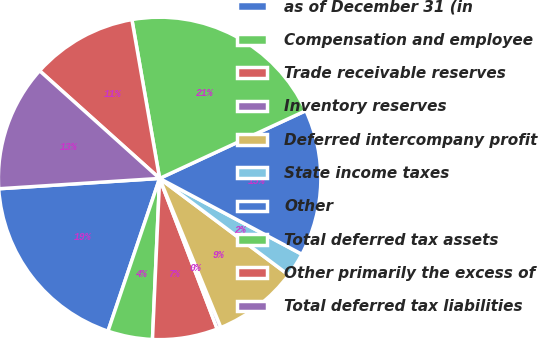<chart> <loc_0><loc_0><loc_500><loc_500><pie_chart><fcel>as of December 31 (in<fcel>Compensation and employee<fcel>Trade receivable reserves<fcel>Inventory reserves<fcel>Deferred intercompany profit<fcel>State income taxes<fcel>Other<fcel>Total deferred tax assets<fcel>Other primarily the excess of<fcel>Total deferred tax liabilities<nl><fcel>18.79%<fcel>4.48%<fcel>6.52%<fcel>0.39%<fcel>8.57%<fcel>2.43%<fcel>14.7%<fcel>20.84%<fcel>10.61%<fcel>12.66%<nl></chart> 